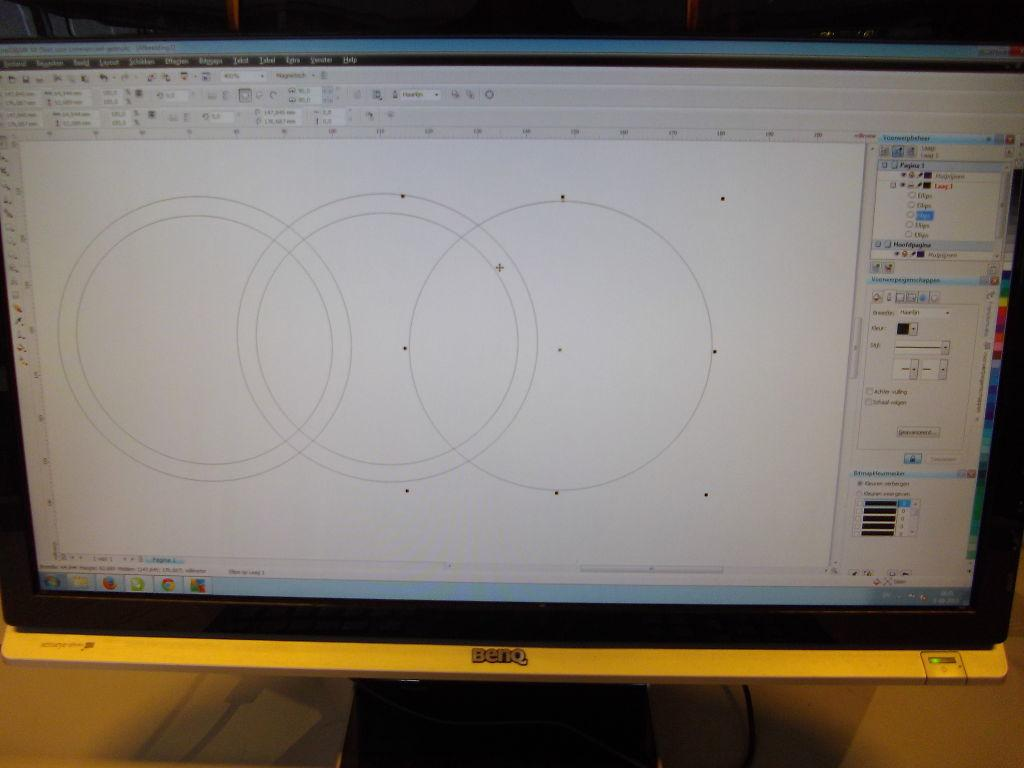Provide a one-sentence caption for the provided image. A Benq computer is open and has a program loaded that is showing drawings of circles. 